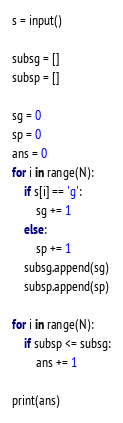Convert code to text. <code><loc_0><loc_0><loc_500><loc_500><_Python_>s = input()

subsg = []
subsp = []

sg = 0
sp = 0
ans = 0
for i in range(N):
    if s[i] == 'g':
        sg += 1
    else:
        sp += 1
    subsg.append(sg)
    subsp.append(sp)

for i in range(N):
    if subsp <= subsg:
        ans += 1
    
print(ans)</code> 